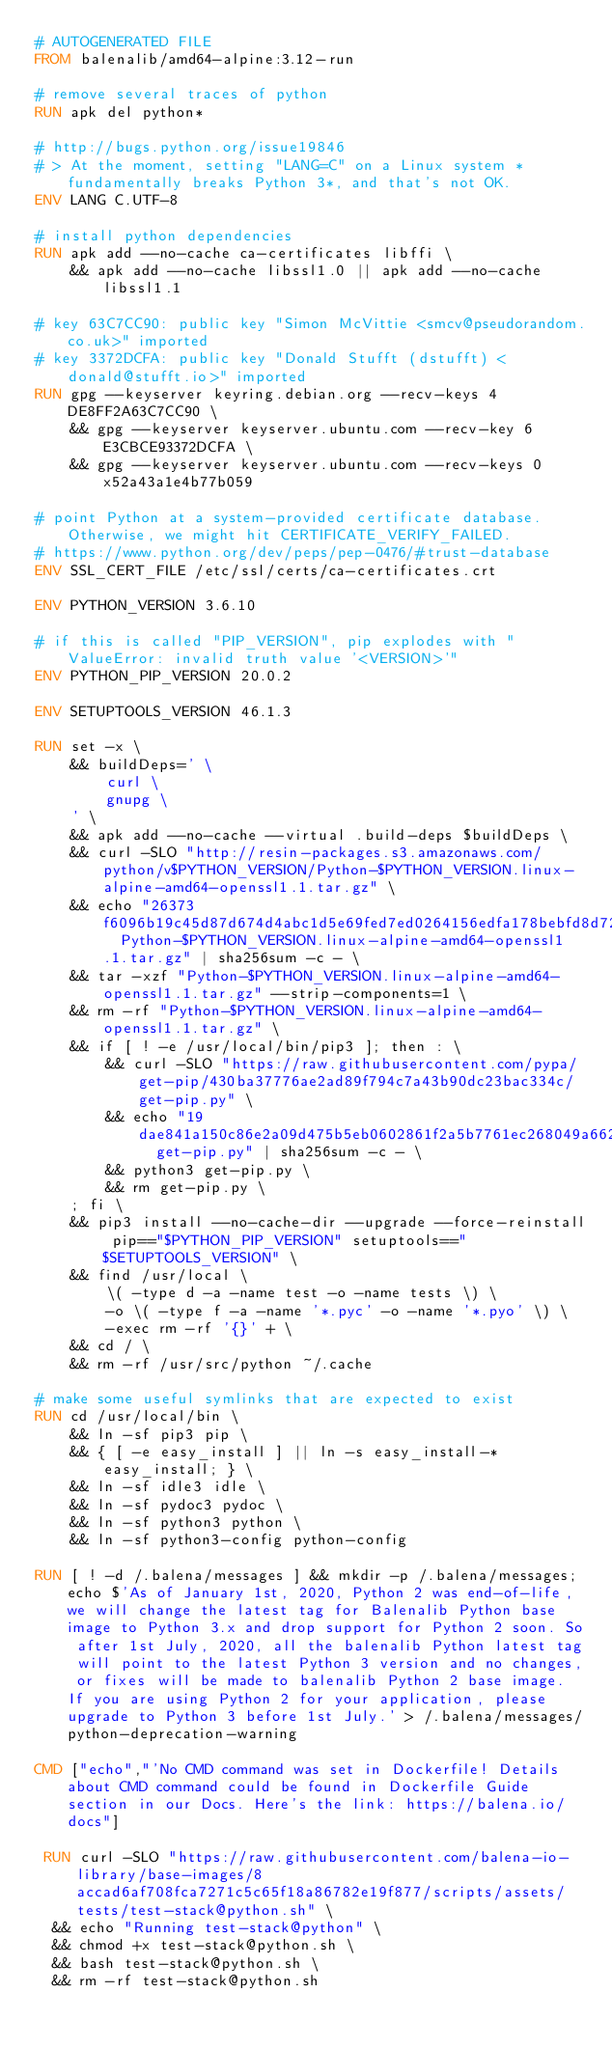Convert code to text. <code><loc_0><loc_0><loc_500><loc_500><_Dockerfile_># AUTOGENERATED FILE
FROM balenalib/amd64-alpine:3.12-run

# remove several traces of python
RUN apk del python*

# http://bugs.python.org/issue19846
# > At the moment, setting "LANG=C" on a Linux system *fundamentally breaks Python 3*, and that's not OK.
ENV LANG C.UTF-8

# install python dependencies
RUN apk add --no-cache ca-certificates libffi \
	&& apk add --no-cache libssl1.0 || apk add --no-cache libssl1.1

# key 63C7CC90: public key "Simon McVittie <smcv@pseudorandom.co.uk>" imported
# key 3372DCFA: public key "Donald Stufft (dstufft) <donald@stufft.io>" imported
RUN gpg --keyserver keyring.debian.org --recv-keys 4DE8FF2A63C7CC90 \
	&& gpg --keyserver keyserver.ubuntu.com --recv-key 6E3CBCE93372DCFA \
	&& gpg --keyserver keyserver.ubuntu.com --recv-keys 0x52a43a1e4b77b059

# point Python at a system-provided certificate database. Otherwise, we might hit CERTIFICATE_VERIFY_FAILED.
# https://www.python.org/dev/peps/pep-0476/#trust-database
ENV SSL_CERT_FILE /etc/ssl/certs/ca-certificates.crt

ENV PYTHON_VERSION 3.6.10

# if this is called "PIP_VERSION", pip explodes with "ValueError: invalid truth value '<VERSION>'"
ENV PYTHON_PIP_VERSION 20.0.2

ENV SETUPTOOLS_VERSION 46.1.3

RUN set -x \
	&& buildDeps=' \
		curl \
		gnupg \
	' \
	&& apk add --no-cache --virtual .build-deps $buildDeps \
	&& curl -SLO "http://resin-packages.s3.amazonaws.com/python/v$PYTHON_VERSION/Python-$PYTHON_VERSION.linux-alpine-amd64-openssl1.1.tar.gz" \
	&& echo "26373f6096b19c45d87d674d4abc1d5e69fed7ed0264156edfa178bebfd8d72a  Python-$PYTHON_VERSION.linux-alpine-amd64-openssl1.1.tar.gz" | sha256sum -c - \
	&& tar -xzf "Python-$PYTHON_VERSION.linux-alpine-amd64-openssl1.1.tar.gz" --strip-components=1 \
	&& rm -rf "Python-$PYTHON_VERSION.linux-alpine-amd64-openssl1.1.tar.gz" \
	&& if [ ! -e /usr/local/bin/pip3 ]; then : \
		&& curl -SLO "https://raw.githubusercontent.com/pypa/get-pip/430ba37776ae2ad89f794c7a43b90dc23bac334c/get-pip.py" \
		&& echo "19dae841a150c86e2a09d475b5eb0602861f2a5b7761ec268049a662dbd2bd0c  get-pip.py" | sha256sum -c - \
		&& python3 get-pip.py \
		&& rm get-pip.py \
	; fi \
	&& pip3 install --no-cache-dir --upgrade --force-reinstall pip=="$PYTHON_PIP_VERSION" setuptools=="$SETUPTOOLS_VERSION" \
	&& find /usr/local \
		\( -type d -a -name test -o -name tests \) \
		-o \( -type f -a -name '*.pyc' -o -name '*.pyo' \) \
		-exec rm -rf '{}' + \
	&& cd / \
	&& rm -rf /usr/src/python ~/.cache

# make some useful symlinks that are expected to exist
RUN cd /usr/local/bin \
	&& ln -sf pip3 pip \
	&& { [ -e easy_install ] || ln -s easy_install-* easy_install; } \
	&& ln -sf idle3 idle \
	&& ln -sf pydoc3 pydoc \
	&& ln -sf python3 python \
	&& ln -sf python3-config python-config

RUN [ ! -d /.balena/messages ] && mkdir -p /.balena/messages; echo $'As of January 1st, 2020, Python 2 was end-of-life, we will change the latest tag for Balenalib Python base image to Python 3.x and drop support for Python 2 soon. So after 1st July, 2020, all the balenalib Python latest tag will point to the latest Python 3 version and no changes, or fixes will be made to balenalib Python 2 base image. If you are using Python 2 for your application, please upgrade to Python 3 before 1st July.' > /.balena/messages/python-deprecation-warning

CMD ["echo","'No CMD command was set in Dockerfile! Details about CMD command could be found in Dockerfile Guide section in our Docs. Here's the link: https://balena.io/docs"]

 RUN curl -SLO "https://raw.githubusercontent.com/balena-io-library/base-images/8accad6af708fca7271c5c65f18a86782e19f877/scripts/assets/tests/test-stack@python.sh" \
  && echo "Running test-stack@python" \
  && chmod +x test-stack@python.sh \
  && bash test-stack@python.sh \
  && rm -rf test-stack@python.sh 
</code> 